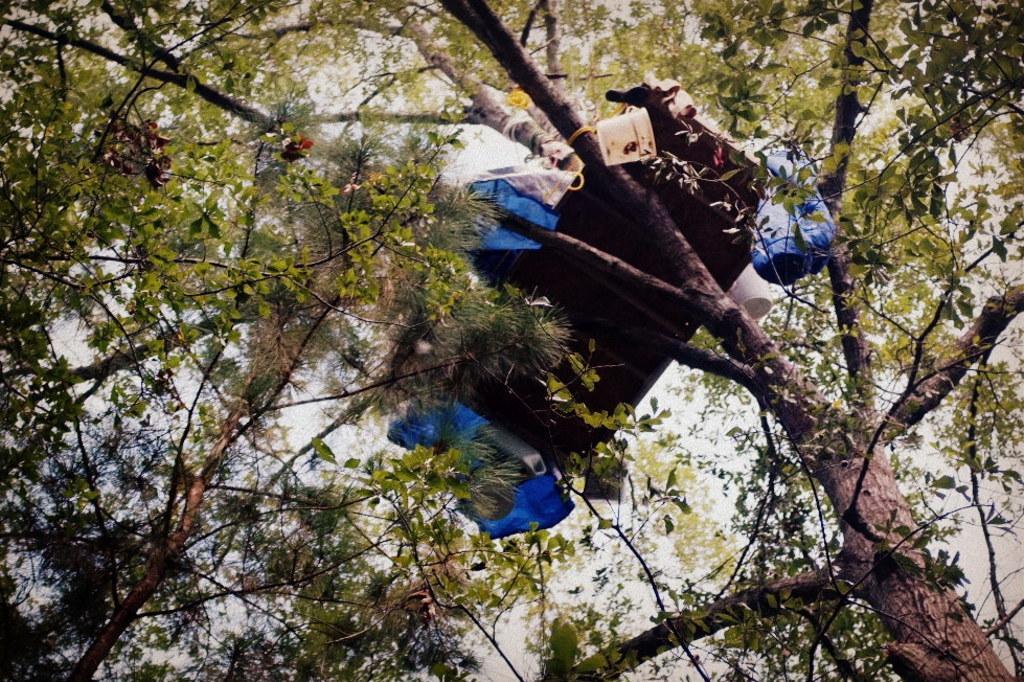Could you give a brief overview of what you see in this image? In this image in the center there is some object on a tree and it looks like a bed, and some bucket, plastic covers and there are some trees. And in the background there is sky. 